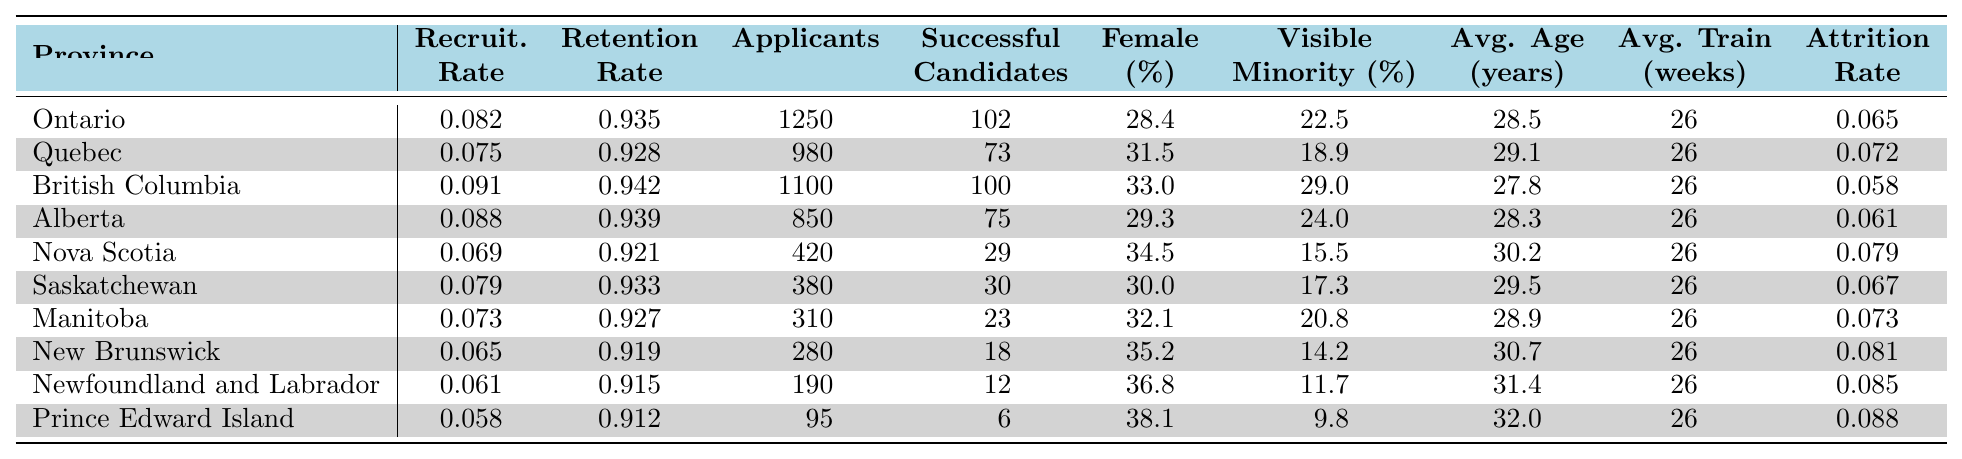What is the recruitment rate in British Columbia? The recruitment rate for British Columbia is directly listed in the table under the column "Recruit. Rate" corresponding to the province. The value is 0.091.
Answer: 0.091 Which province has the highest retention rate? By comparing the "Retention" column, the highest retention rate is found in British Columbia, which has a rate of 0.942.
Answer: British Columbia How many applicants were there in Alberta? The number of applicants for Alberta is found in the "Applicants" column under the appropriate row for Alberta. The number is 850.
Answer: 850 What is the female recruits percentage in Nova Scotia? The percentage of female recruits in Nova Scotia is located in the "Female" column of the table. The value is 34.5%.
Answer: 34.5% Which province has the lowest attrition rate and what is that rate? The lowest attrition rate can be identified by comparing the values in the "Attrition Rate" column. British Columbia has the lowest rate at 0.058.
Answer: 0.058 What is the average age of recruits in Prince Edward Island? To answer this, we can refer to the "Avg. Age" column for the row corresponding to Prince Edward Island, which shows an average age of 32.0 years.
Answer: 32.0 How many successful candidates were there in New Brunswick compared to Manitoba? Looking at the "Successful Candidates" column, New Brunswick had 18 successful candidates while Manitoba had 23. Therefore, Manitoba had 5 more successful candidates than New Brunswick.
Answer: Manitoba had 5 more What is the difference in recruitment rates between Ontario and Quebec? The recruitment rates for Ontario and Quebec are 0.082 and 0.075 respectively. To find the difference, subtract Quebec's rate from Ontario's: 0.082 - 0.075 = 0.007.
Answer: 0.007 Is the percentage of visible minority recruits higher in British Columbia than in Ontario? The visible minority recruits percentage in British Columbia is 29.0%, while in Ontario it is 22.5%. Since 29.0% is greater than 22.5%, the statement is true.
Answer: Yes What is the average training duration across all provinces? The training duration for all provinces is consistently 26 weeks as indicated in the "Avg. Train" column, therefore it is averaged simply as there is no variance.
Answer: 26 weeks Which province has the highest percentage of female recruits and what is that percentage? By analysis of the "Female" column, the highest percentage of female recruits is found in Prince Edward Island at 38.1%.
Answer: 38.1% 